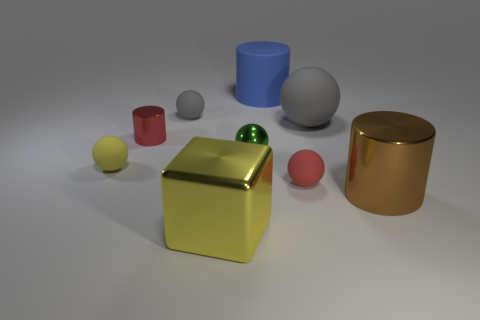What material is the large blue thing?
Your response must be concise. Rubber. Is there anything else that is the same size as the red metal cylinder?
Ensure brevity in your answer.  Yes. There is a red shiny object that is the same shape as the brown thing; what size is it?
Keep it short and to the point. Small. There is a big cylinder that is in front of the large gray ball; is there a metallic block behind it?
Your answer should be very brief. No. Is the large rubber cylinder the same color as the small cylinder?
Offer a very short reply. No. What number of other objects are there of the same shape as the big yellow metal thing?
Give a very brief answer. 0. Is the number of rubber balls on the left side of the big gray ball greater than the number of brown objects left of the small red shiny thing?
Your answer should be compact. Yes. Is the size of the shiny cylinder that is on the left side of the small gray ball the same as the metallic cylinder to the right of the red metallic cylinder?
Keep it short and to the point. No. What shape is the tiny yellow rubber object?
Your answer should be very brief. Sphere. What is the size of the matte sphere that is the same color as the small metallic cylinder?
Keep it short and to the point. Small. 